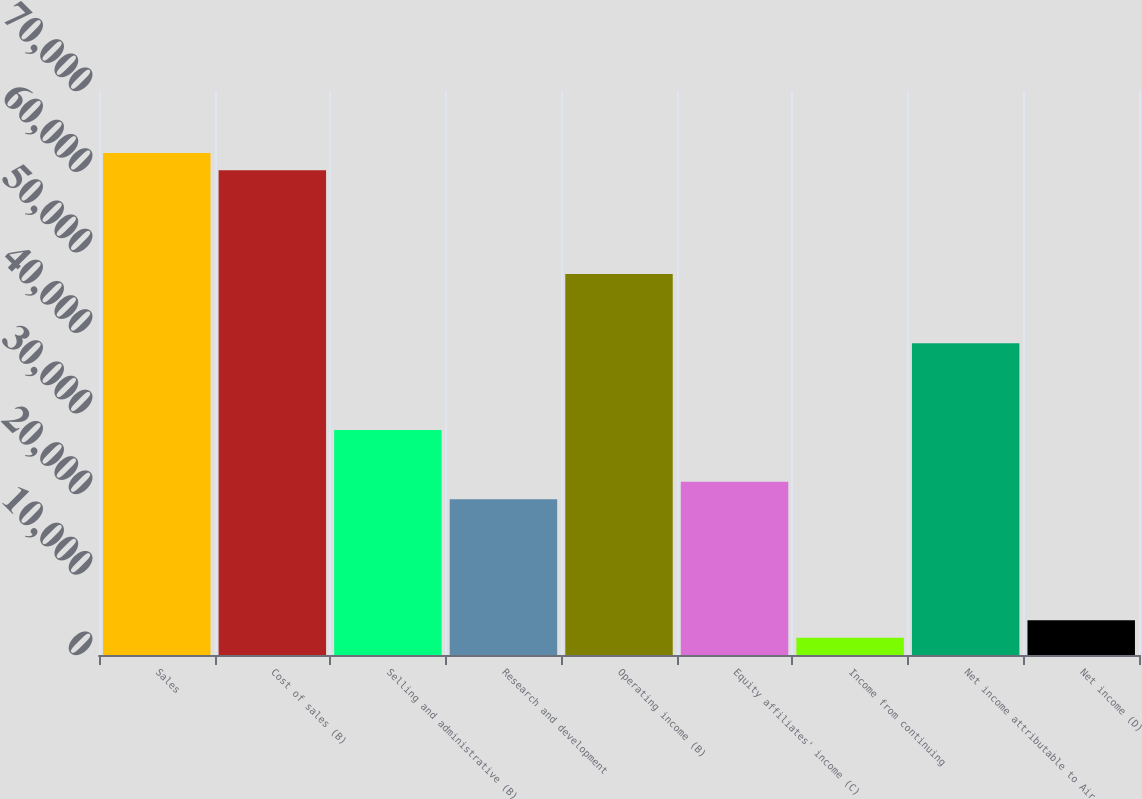Convert chart to OTSL. <chart><loc_0><loc_0><loc_500><loc_500><bar_chart><fcel>Sales<fcel>Cost of sales (B)<fcel>Selling and administrative (B)<fcel>Research and development<fcel>Operating income (B)<fcel>Equity affiliates' income (C)<fcel>Income from continuing<fcel>Net income attributable to Air<fcel>Net income (D)<nl><fcel>62312.9<fcel>60164.3<fcel>27935.7<fcel>19341.5<fcel>47272.9<fcel>21490<fcel>2152.83<fcel>38678.6<fcel>4301.41<nl></chart> 